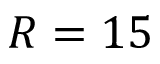<formula> <loc_0><loc_0><loc_500><loc_500>R = 1 5</formula> 